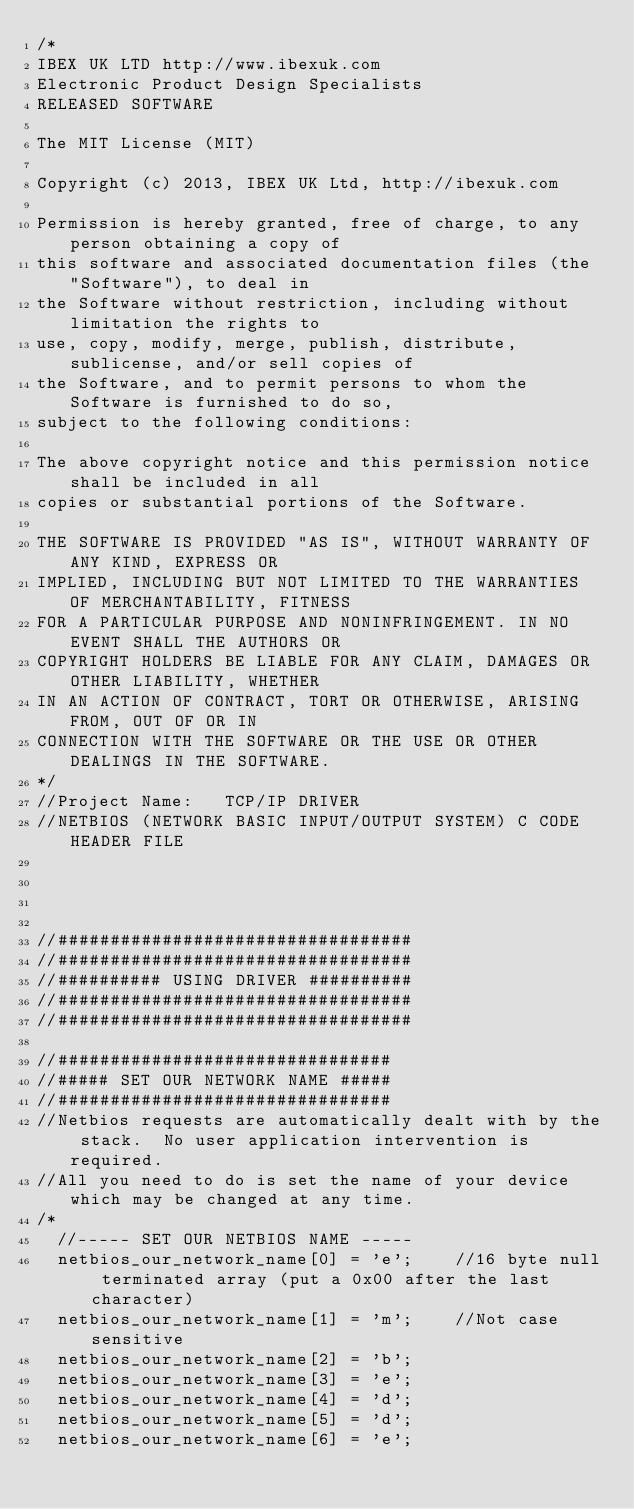<code> <loc_0><loc_0><loc_500><loc_500><_C_>/*
IBEX UK LTD http://www.ibexuk.com
Electronic Product Design Specialists
RELEASED SOFTWARE

The MIT License (MIT)

Copyright (c) 2013, IBEX UK Ltd, http://ibexuk.com

Permission is hereby granted, free of charge, to any person obtaining a copy of
this software and associated documentation files (the "Software"), to deal in
the Software without restriction, including without limitation the rights to
use, copy, modify, merge, publish, distribute, sublicense, and/or sell copies of
the Software, and to permit persons to whom the Software is furnished to do so,
subject to the following conditions:

The above copyright notice and this permission notice shall be included in all
copies or substantial portions of the Software.

THE SOFTWARE IS PROVIDED "AS IS", WITHOUT WARRANTY OF ANY KIND, EXPRESS OR
IMPLIED, INCLUDING BUT NOT LIMITED TO THE WARRANTIES OF MERCHANTABILITY, FITNESS
FOR A PARTICULAR PURPOSE AND NONINFRINGEMENT. IN NO EVENT SHALL THE AUTHORS OR
COPYRIGHT HOLDERS BE LIABLE FOR ANY CLAIM, DAMAGES OR OTHER LIABILITY, WHETHER
IN AN ACTION OF CONTRACT, TORT OR OTHERWISE, ARISING FROM, OUT OF OR IN
CONNECTION WITH THE SOFTWARE OR THE USE OR OTHER DEALINGS IN THE SOFTWARE.
*/
//Project Name:		TCP/IP DRIVER
//NETBIOS (NETWORK BASIC INPUT/OUTPUT SYSTEM) C CODE HEADER FILE




//##################################
//##################################
//########## USING DRIVER ##########
//##################################
//##################################

//################################
//##### SET OUR NETWORK NAME #####
//################################
//Netbios requests are automatically dealt with by the stack.  No user application intervention is required.
//All you need to do is set the name of your device which may be changed at any time.
/*
	//----- SET OUR NETBIOS NAME -----
	netbios_our_network_name[0] = 'e';		//16 byte null terminated array (put a 0x00 after the last character)
	netbios_our_network_name[1] = 'm';		//Not case sensitive
	netbios_our_network_name[2] = 'b';
	netbios_our_network_name[3] = 'e';
	netbios_our_network_name[4] = 'd';
	netbios_our_network_name[5] = 'd';
	netbios_our_network_name[6] = 'e';</code> 